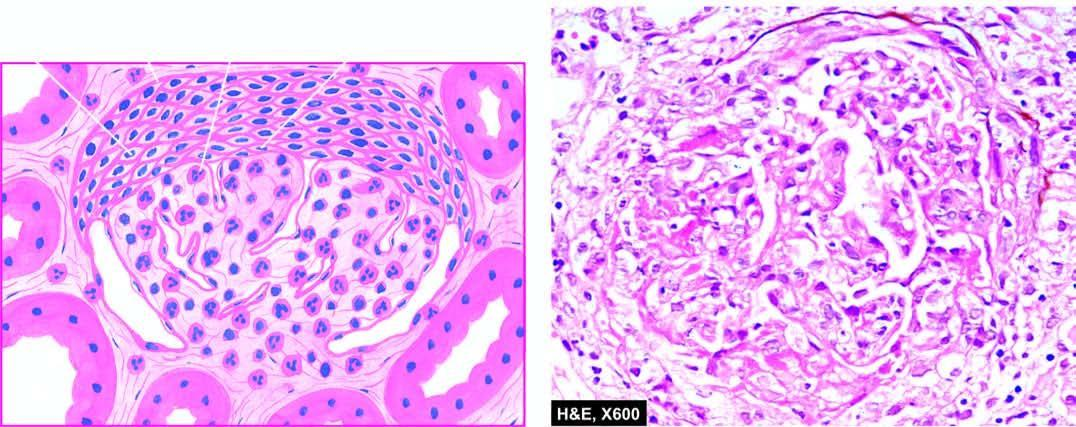what are there in bowman 's space forming adhesions between the glomerular tuft and bowman 's capsule?
Answer the question using a single word or phrase. Crescents in bowman 's space 